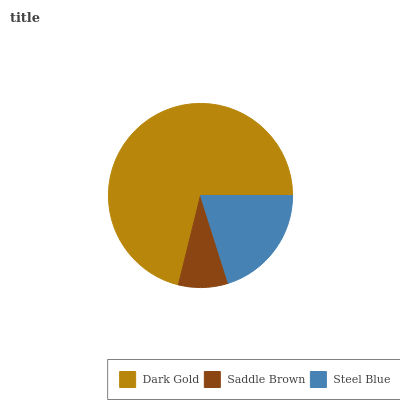Is Saddle Brown the minimum?
Answer yes or no. Yes. Is Dark Gold the maximum?
Answer yes or no. Yes. Is Steel Blue the minimum?
Answer yes or no. No. Is Steel Blue the maximum?
Answer yes or no. No. Is Steel Blue greater than Saddle Brown?
Answer yes or no. Yes. Is Saddle Brown less than Steel Blue?
Answer yes or no. Yes. Is Saddle Brown greater than Steel Blue?
Answer yes or no. No. Is Steel Blue less than Saddle Brown?
Answer yes or no. No. Is Steel Blue the high median?
Answer yes or no. Yes. Is Steel Blue the low median?
Answer yes or no. Yes. Is Saddle Brown the high median?
Answer yes or no. No. Is Dark Gold the low median?
Answer yes or no. No. 